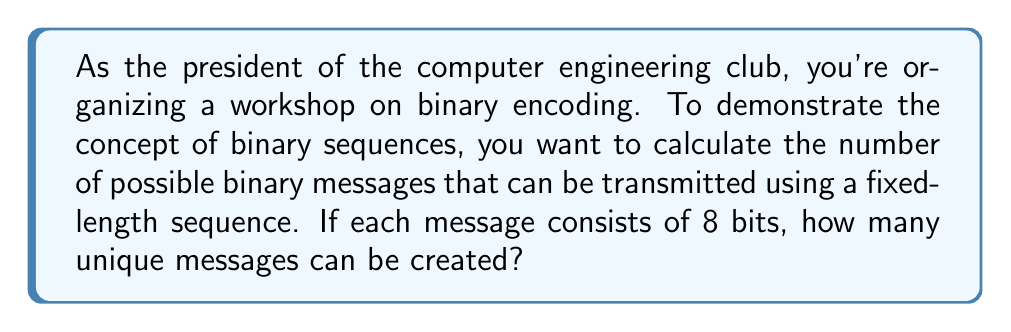Give your solution to this math problem. Let's approach this step-by-step:

1) In a binary sequence, each position can have one of two values: 0 or 1.

2) For each bit in the sequence, we have 2 choices.

3) The sequence has 8 bits in total.

4) According to the multiplication principle, if we have a series of independent choices, the total number of possible outcomes is the product of the number of possibilities for each choice.

5) Therefore, the total number of possible sequences is:

   $$2 \times 2 \times 2 \times 2 \times 2 \times 2 \times 2 \times 2 = 2^8$$

6) We can calculate this:

   $$2^8 = 256$$

Thus, with 8 bits, we can create 256 unique binary messages.
Answer: $256$ 